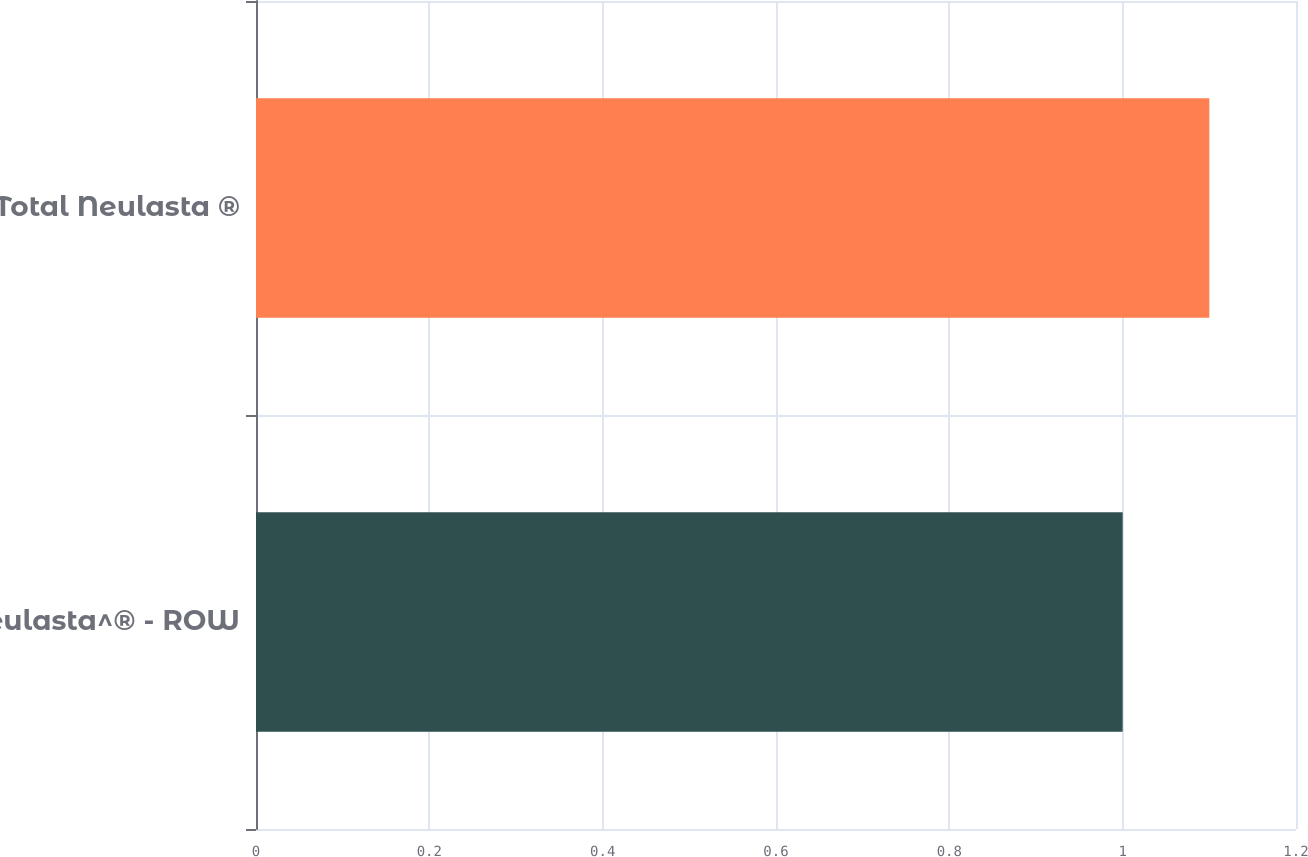Convert chart. <chart><loc_0><loc_0><loc_500><loc_500><bar_chart><fcel>Neulasta^® - ROW<fcel>Total Neulasta ®<nl><fcel>1<fcel>1.1<nl></chart> 